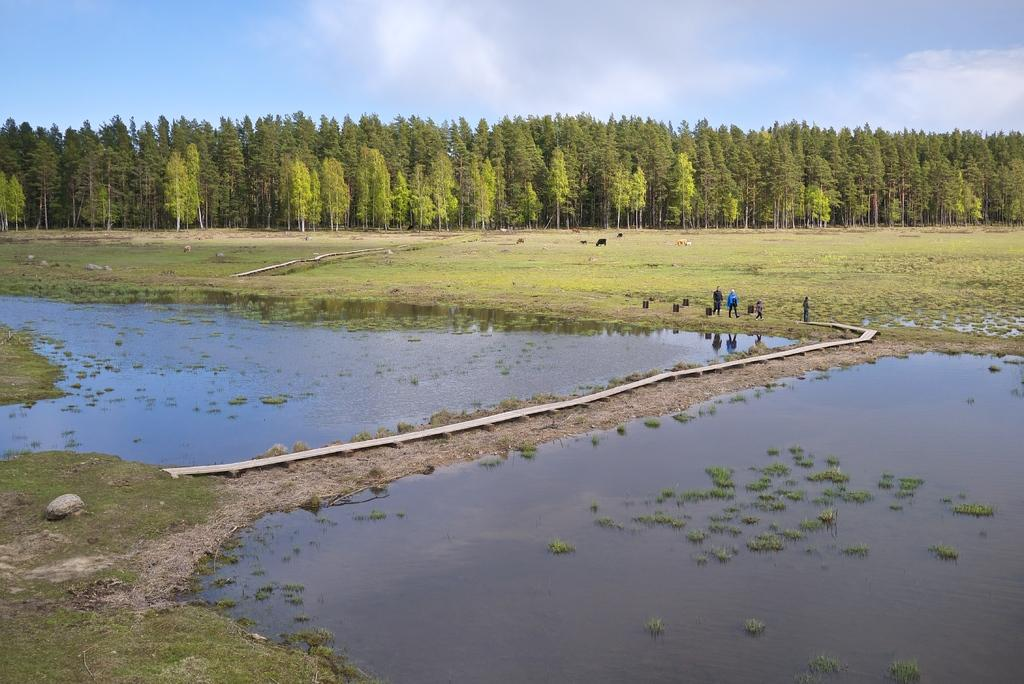What type of body of water is present in the image? There is a lake in the image. What type of terrain surrounds the lake? There is grassy land in the image. What other natural elements can be seen in the image? There are many trees in the image. What is visible at the top of the image? The sky is visible at the top of the image. What can be observed in the sky? There are clouds in the sky. What type of winter activity is taking place on the lake in the image? There is no winter activity or indication of winter in the image; it features a lake, grassy land, trees, and a sky with clouds. How many robins can be seen in the image? There are no robins present in the image. 